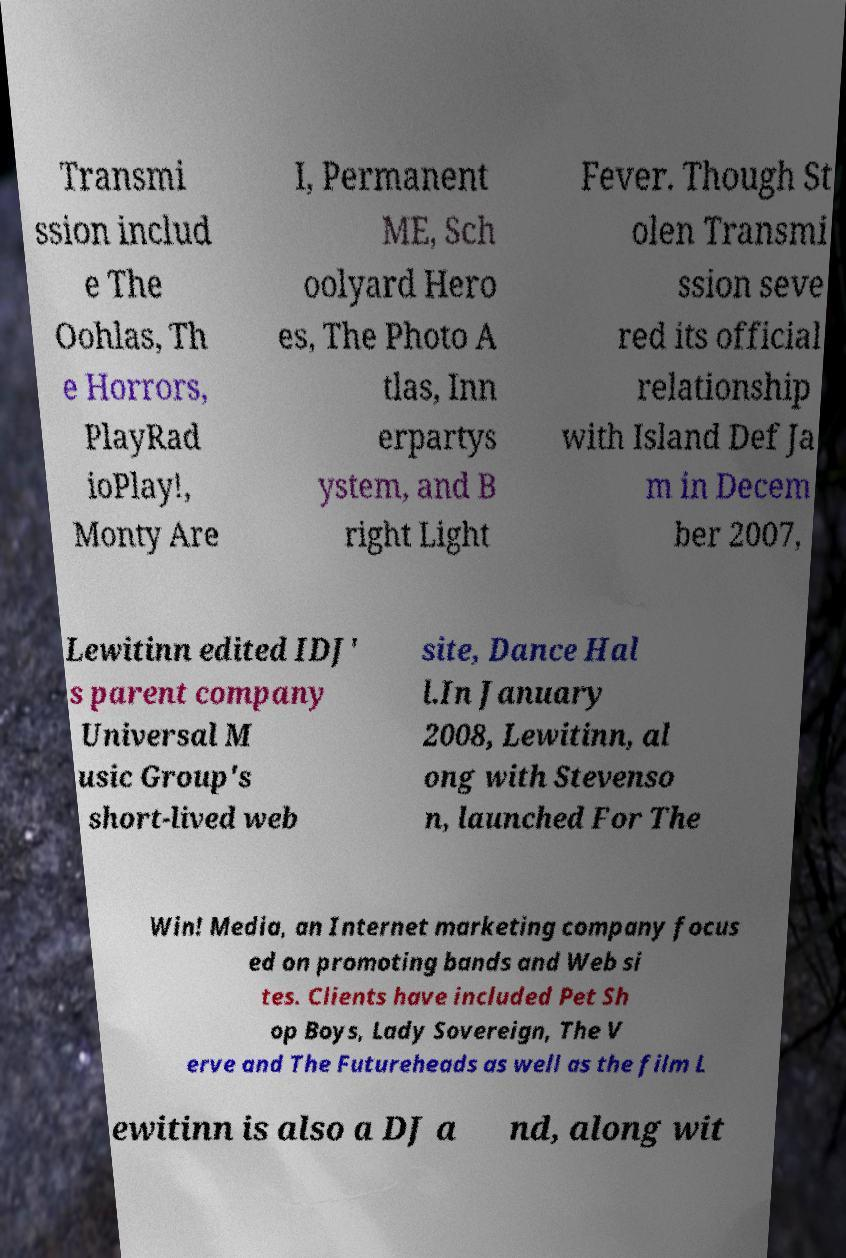Please read and relay the text visible in this image. What does it say? Transmi ssion includ e The Oohlas, Th e Horrors, PlayRad ioPlay!, Monty Are I, Permanent ME, Sch oolyard Hero es, The Photo A tlas, Inn erpartys ystem, and B right Light Fever. Though St olen Transmi ssion seve red its official relationship with Island Def Ja m in Decem ber 2007, Lewitinn edited IDJ' s parent company Universal M usic Group's short-lived web site, Dance Hal l.In January 2008, Lewitinn, al ong with Stevenso n, launched For The Win! Media, an Internet marketing company focus ed on promoting bands and Web si tes. Clients have included Pet Sh op Boys, Lady Sovereign, The V erve and The Futureheads as well as the film L ewitinn is also a DJ a nd, along wit 